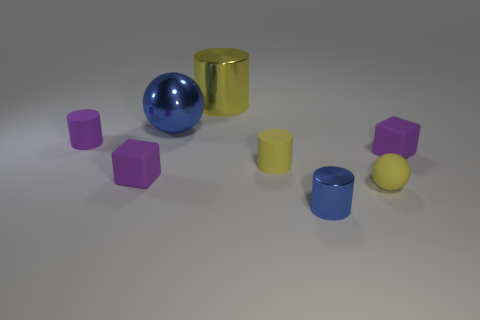Subtract all cyan cylinders. Subtract all green spheres. How many cylinders are left? 4 Add 1 small red metal objects. How many objects exist? 9 Subtract all spheres. How many objects are left? 6 Add 2 small purple rubber cylinders. How many small purple rubber cylinders are left? 3 Add 3 tiny rubber spheres. How many tiny rubber spheres exist? 4 Subtract 0 yellow blocks. How many objects are left? 8 Subtract all tiny brown rubber balls. Subtract all yellow cylinders. How many objects are left? 6 